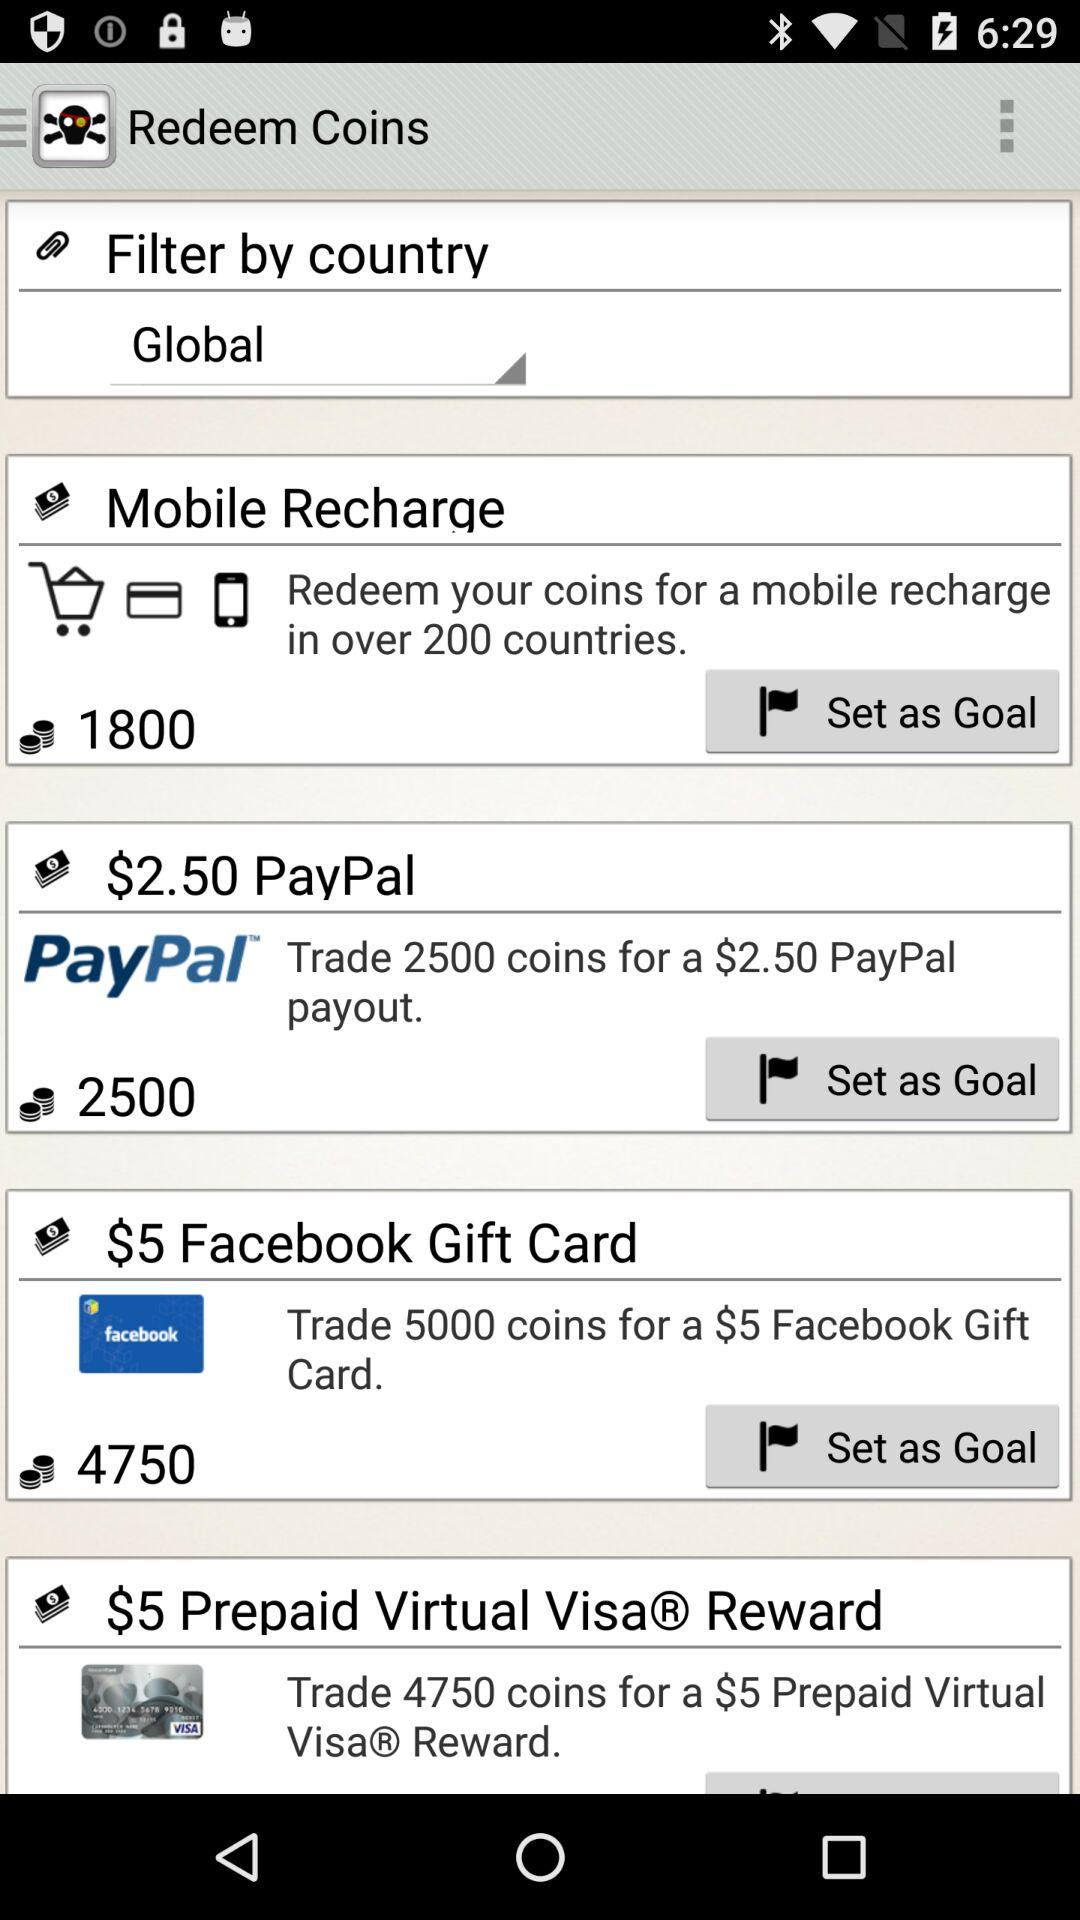How many more coins are needed to redeem a $5 Prepaid Virtual Visa® Reward than a $2.50 PayPal payout?
Answer the question using a single word or phrase. 2250 